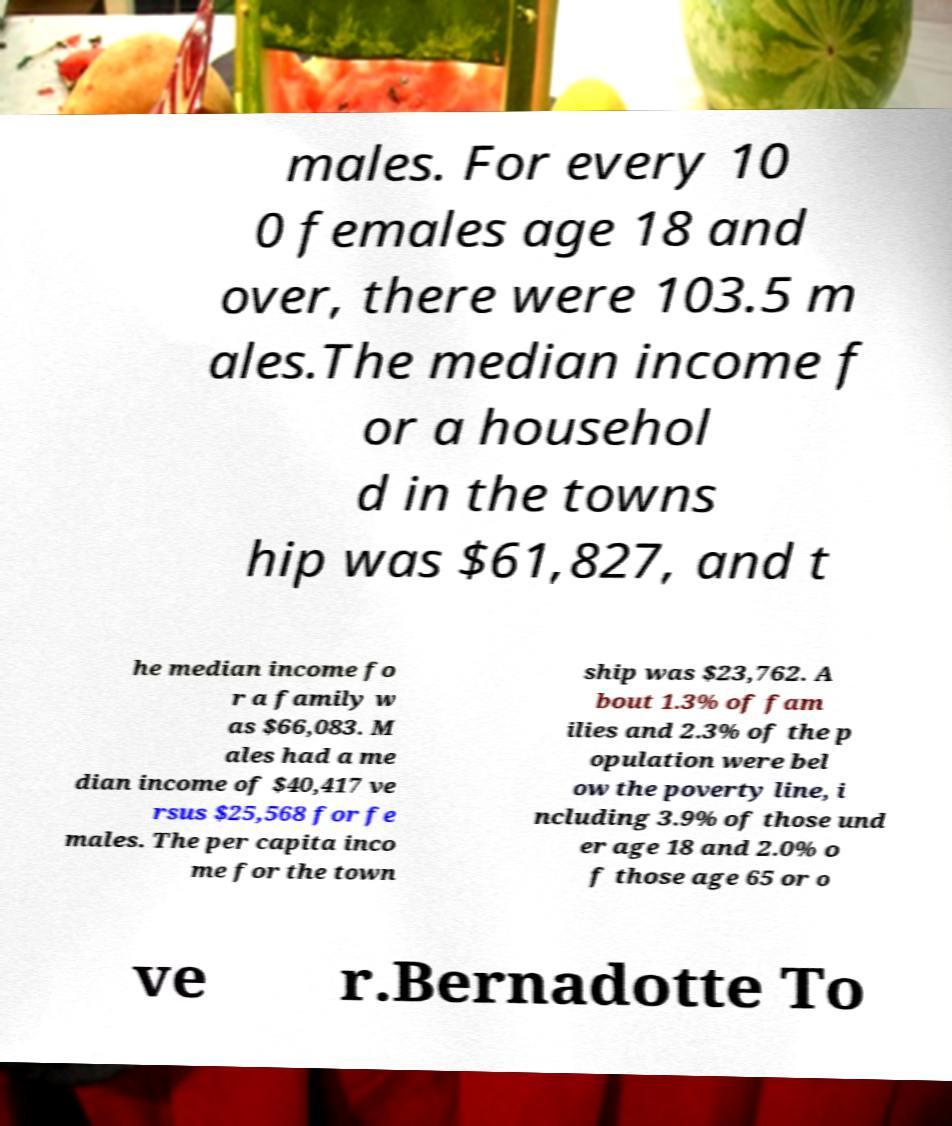Can you read and provide the text displayed in the image?This photo seems to have some interesting text. Can you extract and type it out for me? males. For every 10 0 females age 18 and over, there were 103.5 m ales.The median income f or a househol d in the towns hip was $61,827, and t he median income fo r a family w as $66,083. M ales had a me dian income of $40,417 ve rsus $25,568 for fe males. The per capita inco me for the town ship was $23,762. A bout 1.3% of fam ilies and 2.3% of the p opulation were bel ow the poverty line, i ncluding 3.9% of those und er age 18 and 2.0% o f those age 65 or o ve r.Bernadotte To 